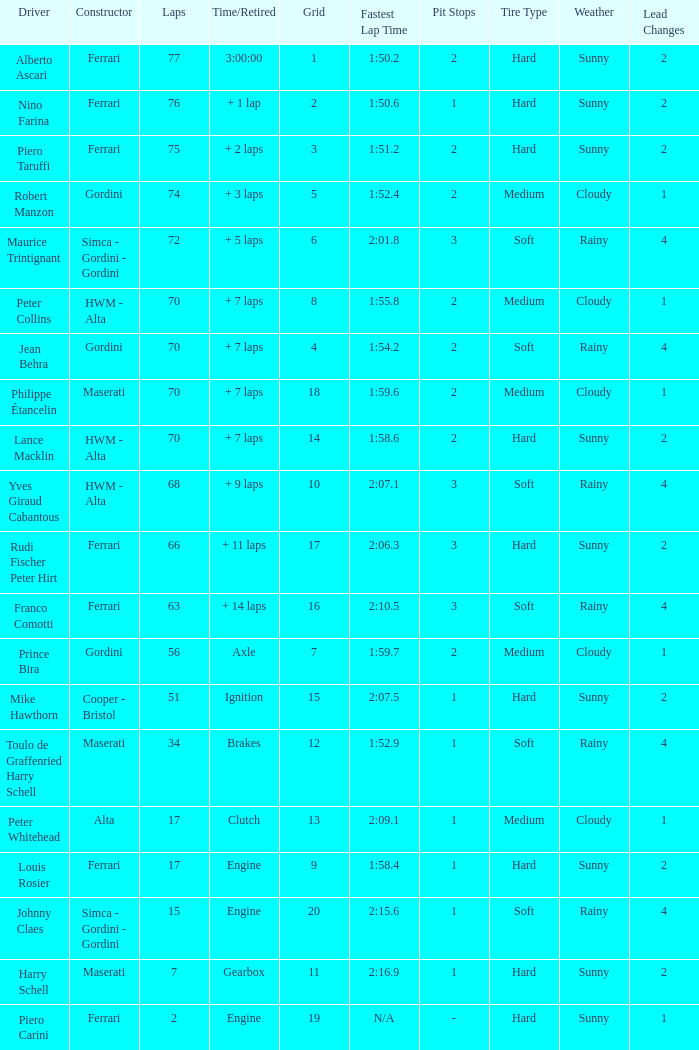How many grids for peter collins? 1.0. 